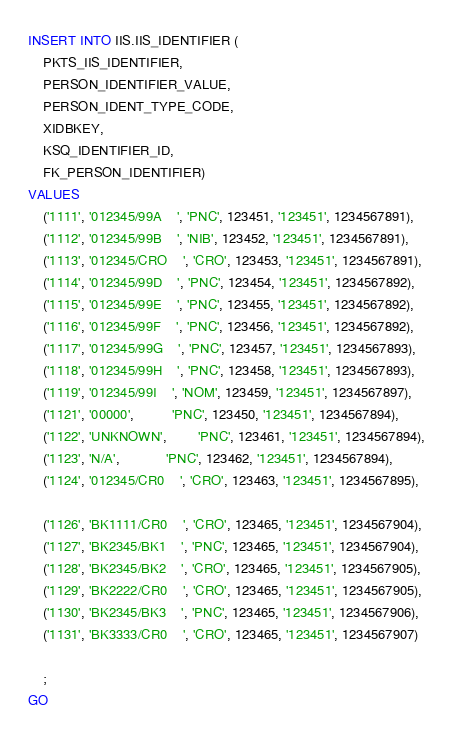Convert code to text. <code><loc_0><loc_0><loc_500><loc_500><_SQL_>INSERT INTO IIS.IIS_IDENTIFIER (
    PKTS_IIS_IDENTIFIER,
    PERSON_IDENTIFIER_VALUE,
    PERSON_IDENT_TYPE_CODE,
    XIDBKEY,
    KSQ_IDENTIFIER_ID,
    FK_PERSON_IDENTIFIER)
VALUES
    ('1111', '012345/99A    ', 'PNC', 123451, '123451', 1234567891),
    ('1112', '012345/99B    ', 'NIB', 123452, '123451', 1234567891),
    ('1113', '012345/CRO    ', 'CRO', 123453, '123451', 1234567891),
    ('1114', '012345/99D    ', 'PNC', 123454, '123451', 1234567892),
    ('1115', '012345/99E    ', 'PNC', 123455, '123451', 1234567892),
    ('1116', '012345/99F    ', 'PNC', 123456, '123451', 1234567892),
    ('1117', '012345/99G    ', 'PNC', 123457, '123451', 1234567893),
    ('1118', '012345/99H    ', 'PNC', 123458, '123451', 1234567893),
    ('1119', '012345/99I    ', 'NOM', 123459, '123451', 1234567897),
    ('1121', '00000',          'PNC', 123450, '123451', 1234567894),
    ('1122', 'UNKNOWN',        'PNC', 123461, '123451', 1234567894),
    ('1123', 'N/A',            'PNC', 123462, '123451', 1234567894),
    ('1124', '012345/CR0    ', 'CRO', 123463, '123451', 1234567895),

    ('1126', 'BK1111/CR0    ', 'CRO', 123465, '123451', 1234567904),
    ('1127', 'BK2345/BK1    ', 'PNC', 123465, '123451', 1234567904),
    ('1128', 'BK2345/BK2    ', 'CRO', 123465, '123451', 1234567905),
    ('1129', 'BK2222/CR0    ', 'CRO', 123465, '123451', 1234567905),
    ('1130', 'BK2345/BK3    ', 'PNC', 123465, '123451', 1234567906),
    ('1131', 'BK3333/CR0    ', 'CRO', 123465, '123451', 1234567907)

    ;
GO
</code> 